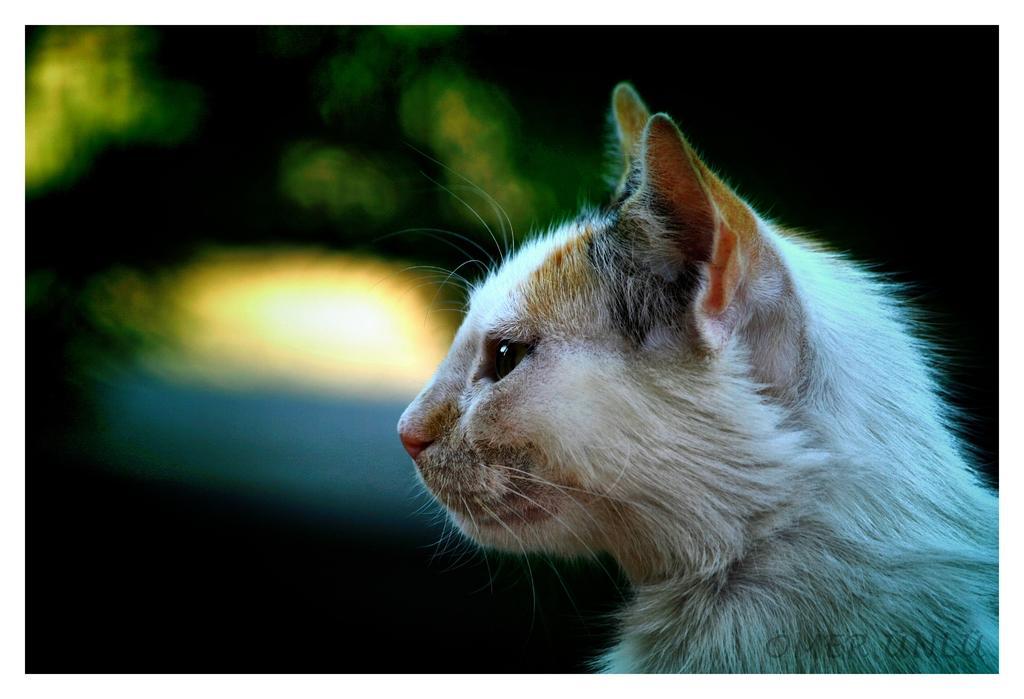In one or two sentences, can you explain what this image depicts? In this image, we can see a cat and there is a blurred background. 